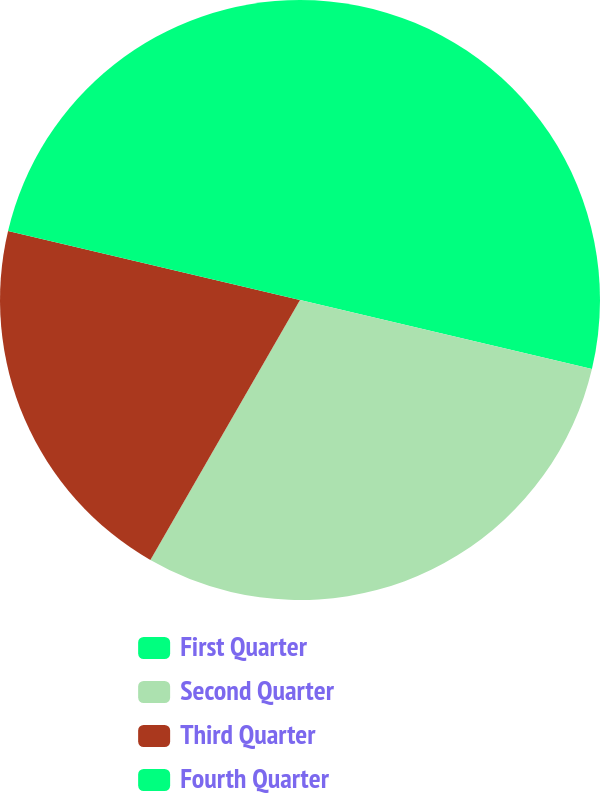Convert chart to OTSL. <chart><loc_0><loc_0><loc_500><loc_500><pie_chart><fcel>First Quarter<fcel>Second Quarter<fcel>Third Quarter<fcel>Fourth Quarter<nl><fcel>28.7%<fcel>29.61%<fcel>20.39%<fcel>21.3%<nl></chart> 